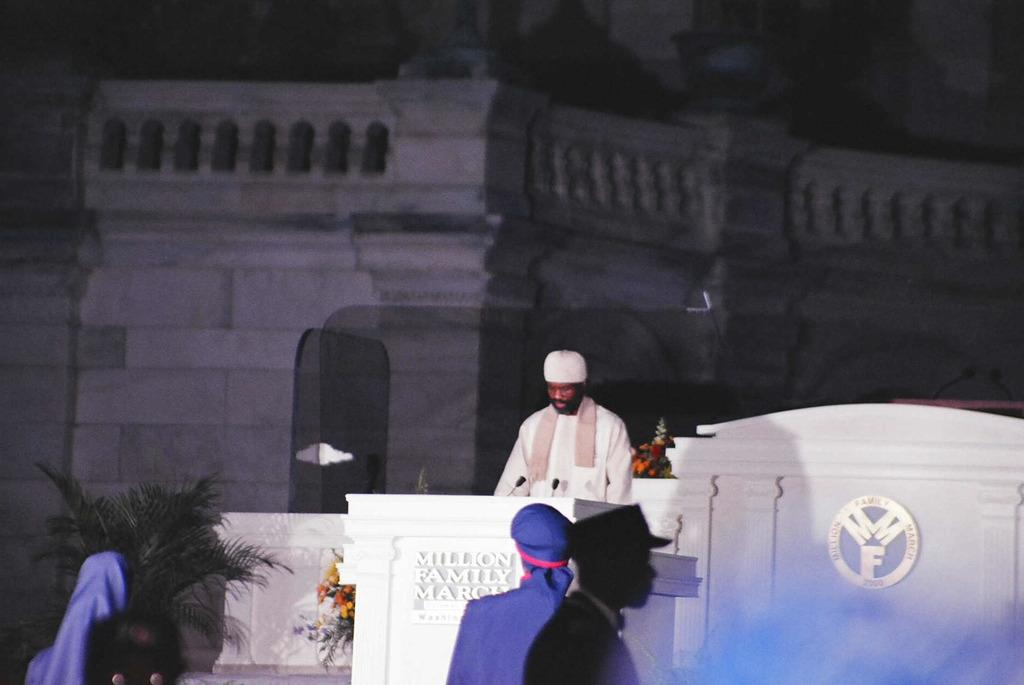How many people are in the image? There are four people standing in the image. What is the person near the podium doing? The person is standing near a podium. What can be found on the podium? There are microphones on the podium. What type of structure is visible in the image? There is a building visible in the image. What decorative items are present in the image? Flower bouquets and a plant are present in the image. What type of stone is the zebra standing on in the image? There is no zebra present in the image, and therefore no stone for it to stand on. 